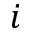<formula> <loc_0><loc_0><loc_500><loc_500>i</formula> 